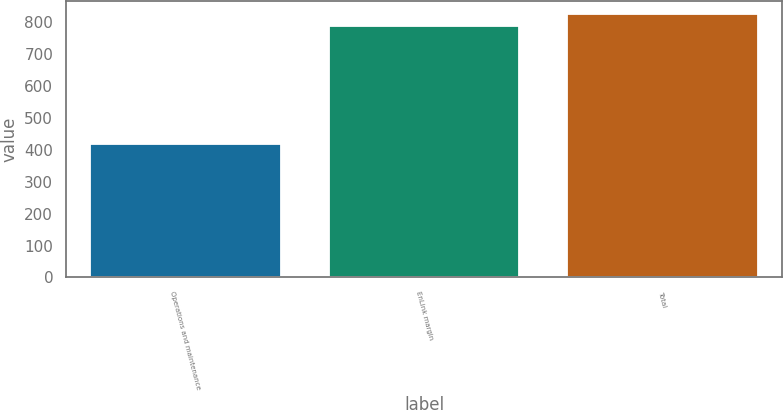Convert chart to OTSL. <chart><loc_0><loc_0><loc_500><loc_500><bar_chart><fcel>Operations and maintenance<fcel>EnLink margin<fcel>Total<nl><fcel>419<fcel>787<fcel>825<nl></chart> 